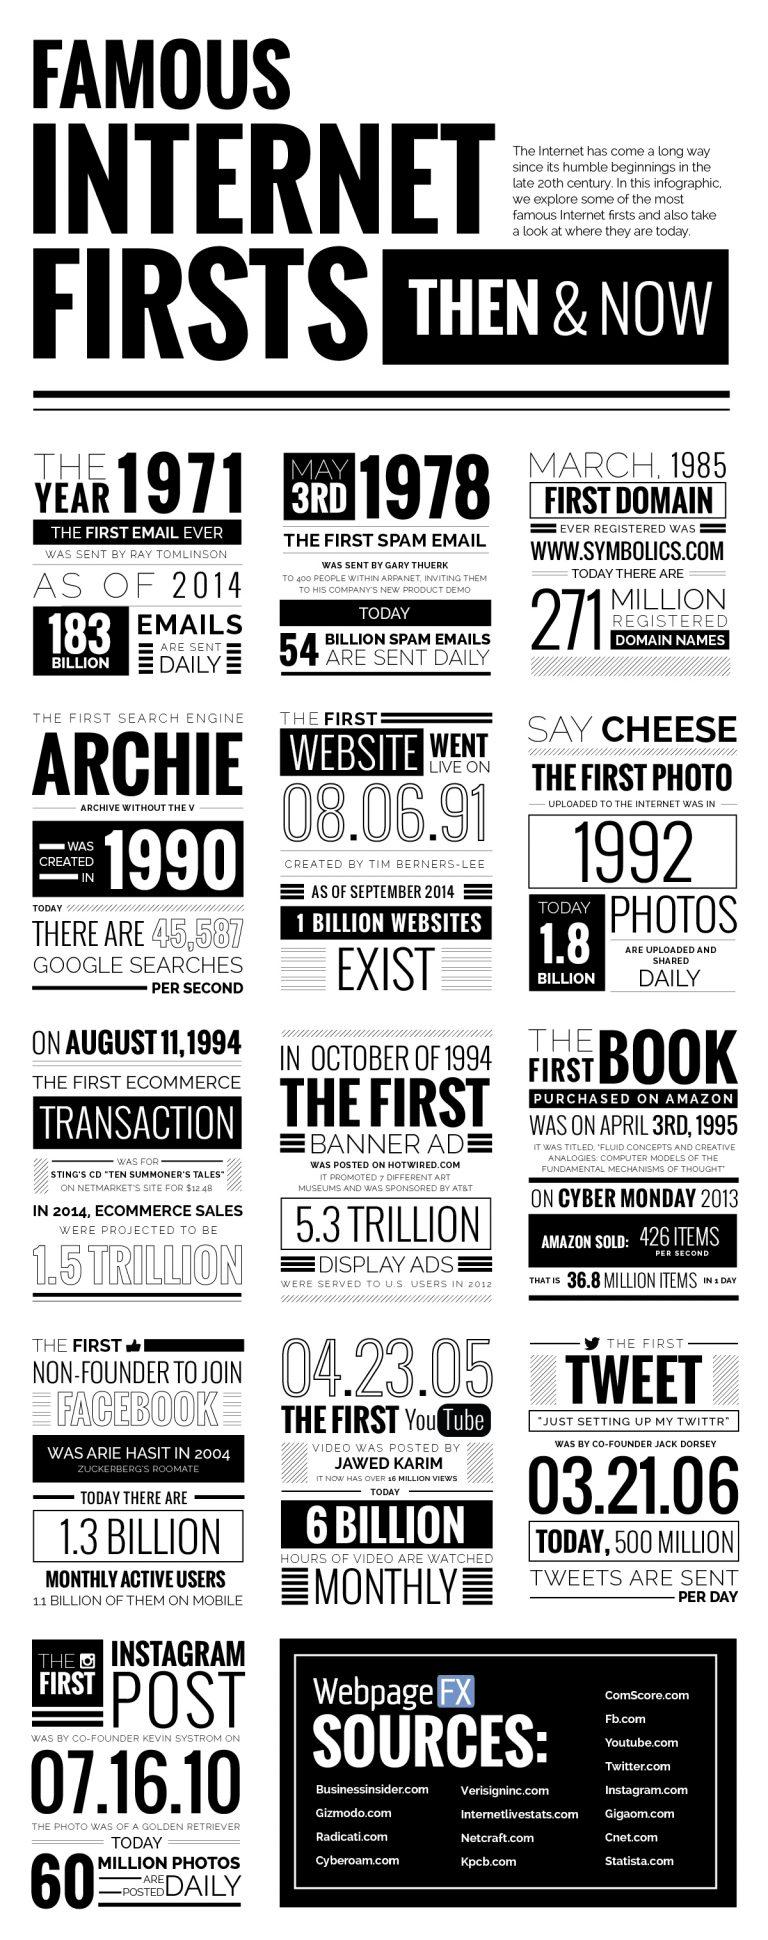List a handful of essential elements in this visual. I have received 16 million views for my first YouTube video. The first tweet was made on March 21, 2006, by Jack Dorsey, who simply stated, "Just setting up my twittr..". Gary Thuerk is known as the person who sent the first spam email. The first photograph was uploaded to the internet in 1992. The person who posted the first YouTube video is named Jawed Karim. 